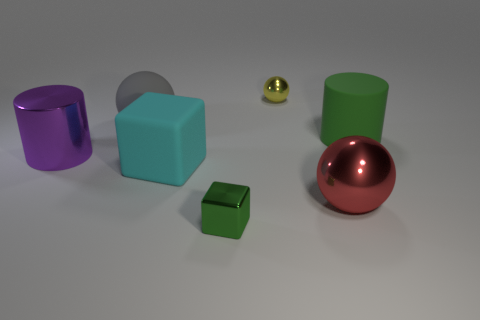Subtract all big gray rubber balls. How many balls are left? 2 Subtract all cubes. How many objects are left? 5 Add 1 red balls. How many objects exist? 8 Subtract 1 cylinders. How many cylinders are left? 1 Subtract all cyan blocks. How many blocks are left? 1 Subtract all purple cubes. How many purple cylinders are left? 1 Subtract all large purple metal cylinders. Subtract all large objects. How many objects are left? 1 Add 2 red spheres. How many red spheres are left? 3 Add 1 yellow spheres. How many yellow spheres exist? 2 Subtract 1 green cubes. How many objects are left? 6 